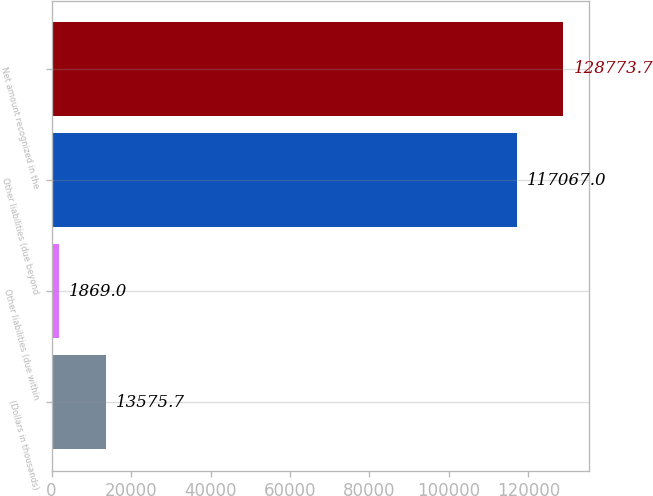Convert chart to OTSL. <chart><loc_0><loc_0><loc_500><loc_500><bar_chart><fcel>(Dollars in thousands)<fcel>Other liabilities (due within<fcel>Other liabilities (due beyond<fcel>Net amount recognized in the<nl><fcel>13575.7<fcel>1869<fcel>117067<fcel>128774<nl></chart> 